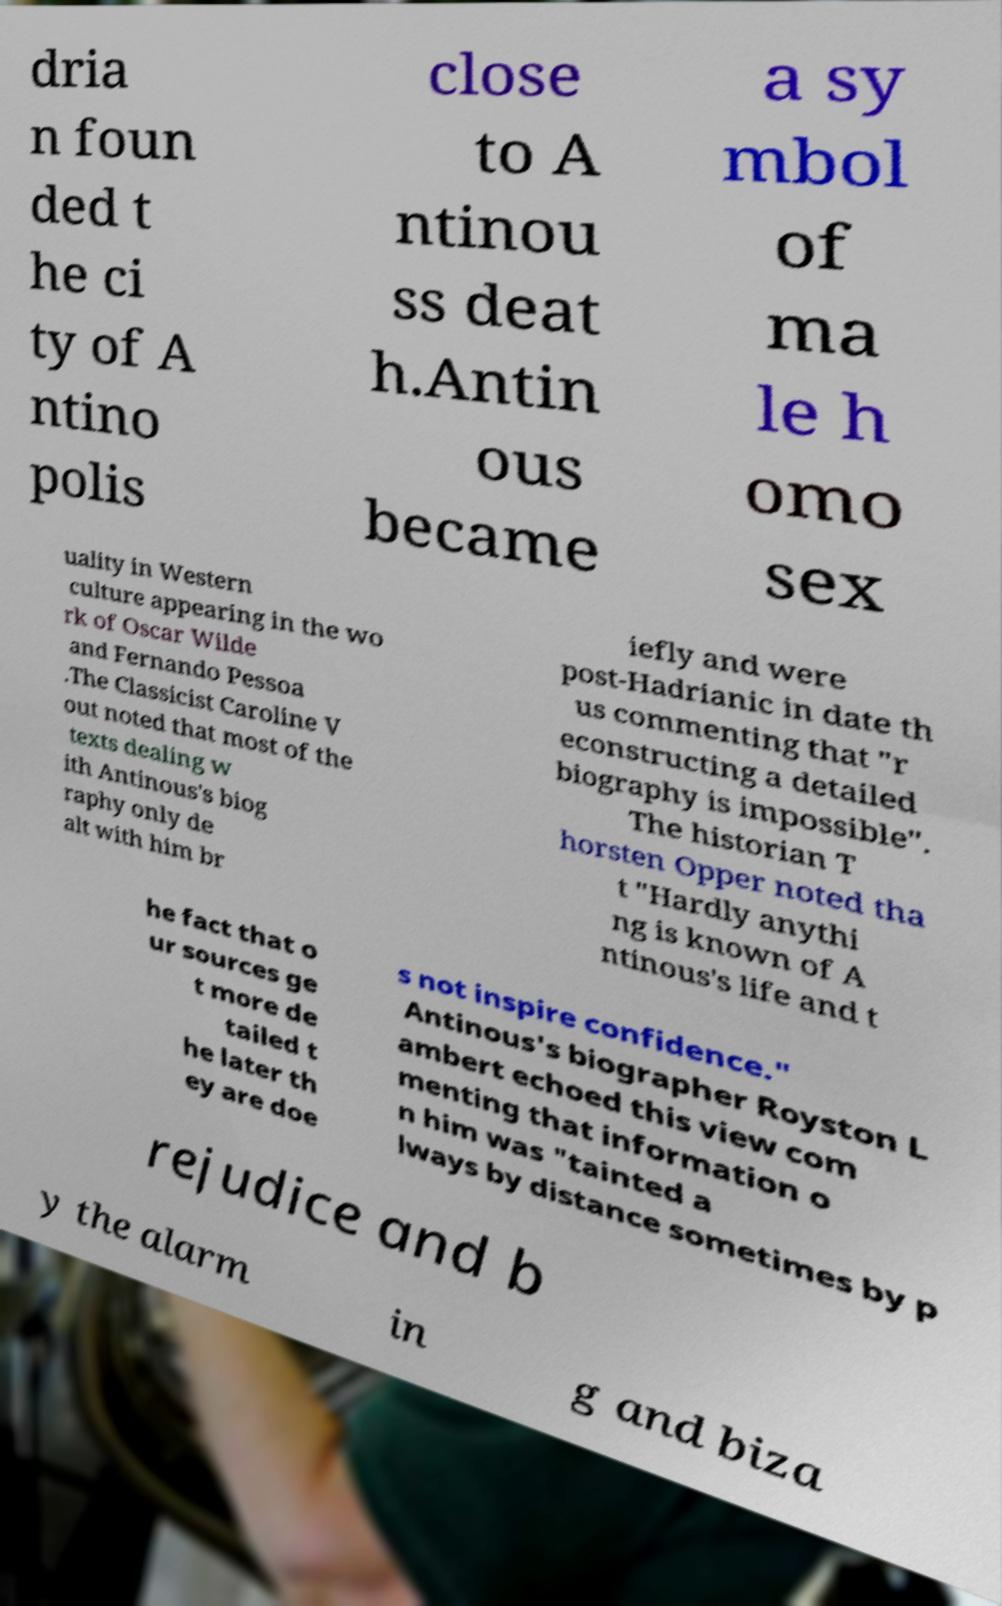Can you accurately transcribe the text from the provided image for me? dria n foun ded t he ci ty of A ntino polis close to A ntinou ss deat h.Antin ous became a sy mbol of ma le h omo sex uality in Western culture appearing in the wo rk of Oscar Wilde and Fernando Pessoa .The Classicist Caroline V out noted that most of the texts dealing w ith Antinous's biog raphy only de alt with him br iefly and were post-Hadrianic in date th us commenting that "r econstructing a detailed biography is impossible". The historian T horsten Opper noted tha t "Hardly anythi ng is known of A ntinous's life and t he fact that o ur sources ge t more de tailed t he later th ey are doe s not inspire confidence." Antinous's biographer Royston L ambert echoed this view com menting that information o n him was "tainted a lways by distance sometimes by p rejudice and b y the alarm in g and biza 